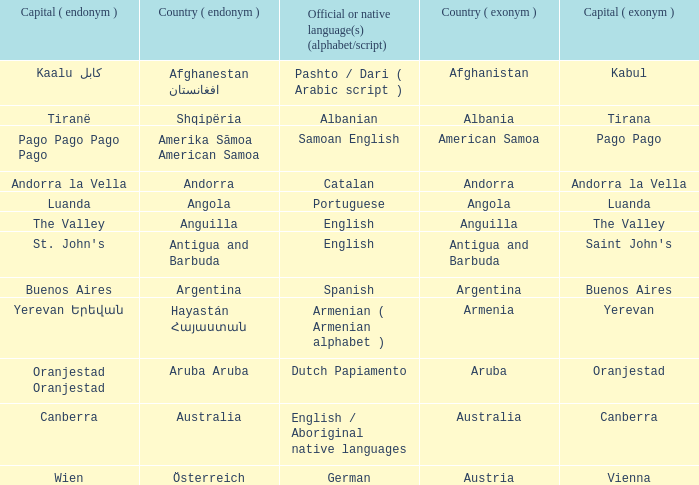What is the English name of the country whose official native language is Dutch Papiamento? Aruba. 